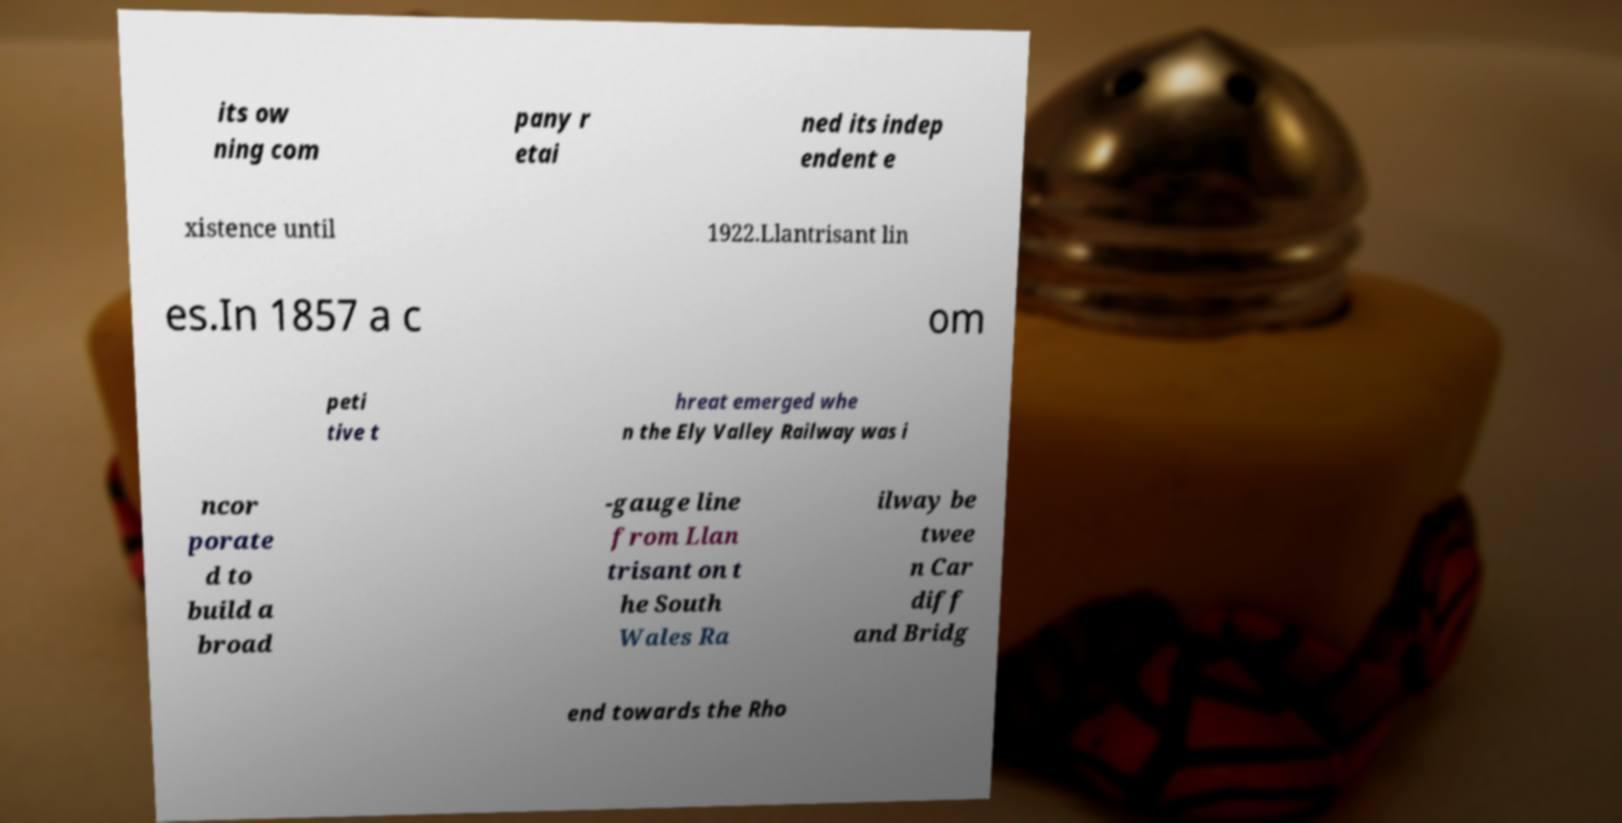Can you accurately transcribe the text from the provided image for me? its ow ning com pany r etai ned its indep endent e xistence until 1922.Llantrisant lin es.In 1857 a c om peti tive t hreat emerged whe n the Ely Valley Railway was i ncor porate d to build a broad -gauge line from Llan trisant on t he South Wales Ra ilway be twee n Car diff and Bridg end towards the Rho 